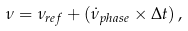Convert formula to latex. <formula><loc_0><loc_0><loc_500><loc_500>\nu = \nu _ { r e f } + ( \dot { \nu } _ { p h a s e } \times \Delta t ) \, ,</formula> 